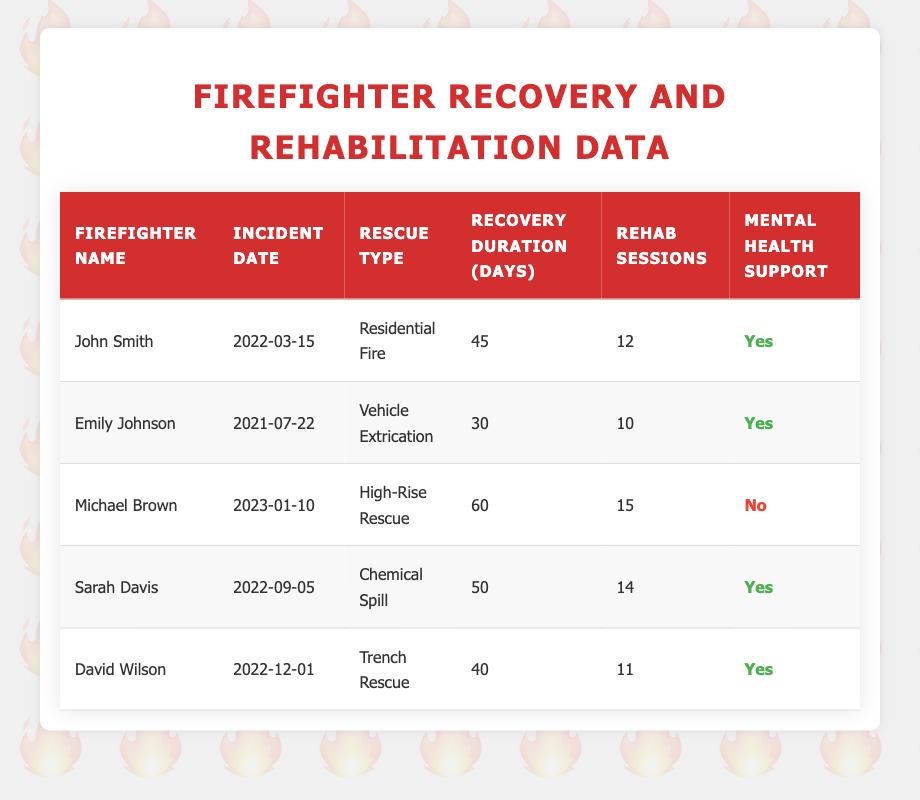What is the duration of recovery for John Smith? The table indicates that John Smith has a recovery duration of 45 days following a Residential Fire incident.
Answer: 45 days How many rehabilitation sessions did Emily Johnson have? According to the table, Emily Johnson had a total of 10 rehabilitation sessions after her Vehicle Extrication incident.
Answer: 10 sessions Which firefighter had the longest recovery duration? By examining the duration of recovery for all firefighters, Michael Brown had the longest duration at 60 days following his High-Rise Rescue incident.
Answer: Michael Brown Is mental health support provided for Sarah Davis? The table states that Sarah Davis received mental health support after the Chemical Spill incident, as indicated by the 'Yes' in the mental health support column.
Answer: Yes What is the average duration of recovery for the firefighters listed? To find the average, sum the recovery durations (45 + 30 + 60 + 50 + 40 = 225) and divide by the number of firefighters (5). The average duration of recovery is 225 / 5 = 45 days.
Answer: 45 days How many firefighters received mental health support? By checking the mental health support column, 4 out of 5 firefighters received mental health support, as indicated by the 'Yes' responses.
Answer: 4 firefighters What is the difference in recovery duration between the shortest and longest recovery times? The shortest recovery duration is 30 days (Emily Johnson) and the longest is 60 days (Michael Brown). The difference is calculated as 60 - 30 = 30 days.
Answer: 30 days Which rescue type had the most rehabilitation sessions on average? The rehabilitation sessions are: Residential Fire (12), Vehicle Extrication (10), High-Rise Rescue (15), Chemical Spill (14), and Trench Rescue (11). Calculate the average: (12 + 10 + 15 + 14 + 11) / 5 = 12. This means the average number of rehabilitation sessions is 12.
Answer: 12 sessions How many days did David Wilson spend in recovery? The table specifies that David Wilson spent 40 days in recovery following his Trench Rescue incident.
Answer: 40 days 